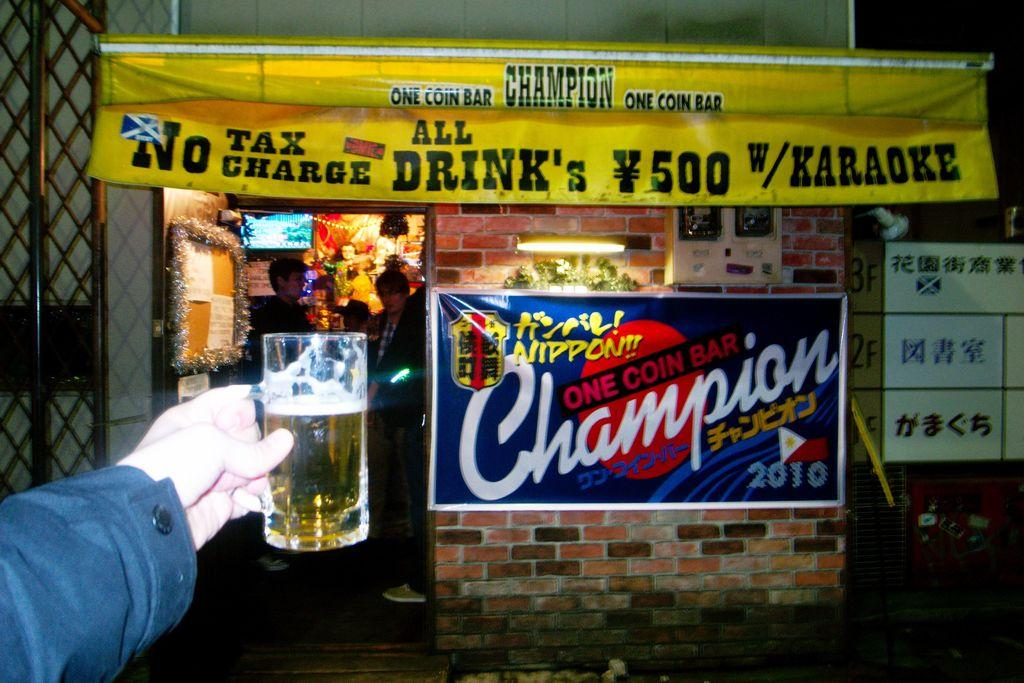Who is present in the image? There is a person in the image. What is the person holding in the image? The person is holding a glass. What can be seen in the background of the image? There is a store visible in the background, and there are people in the background. What is attached to the wall in the image? Banners are attached to the wall. How many colors are the banners in the image? The banners are in different colors. What other object can be seen in the image? There is an iron pole in the image. Where is the drawer located in the image? There is no drawer present in the image. What type of butter is being used by the person in the image? There is no butter present in the image. 